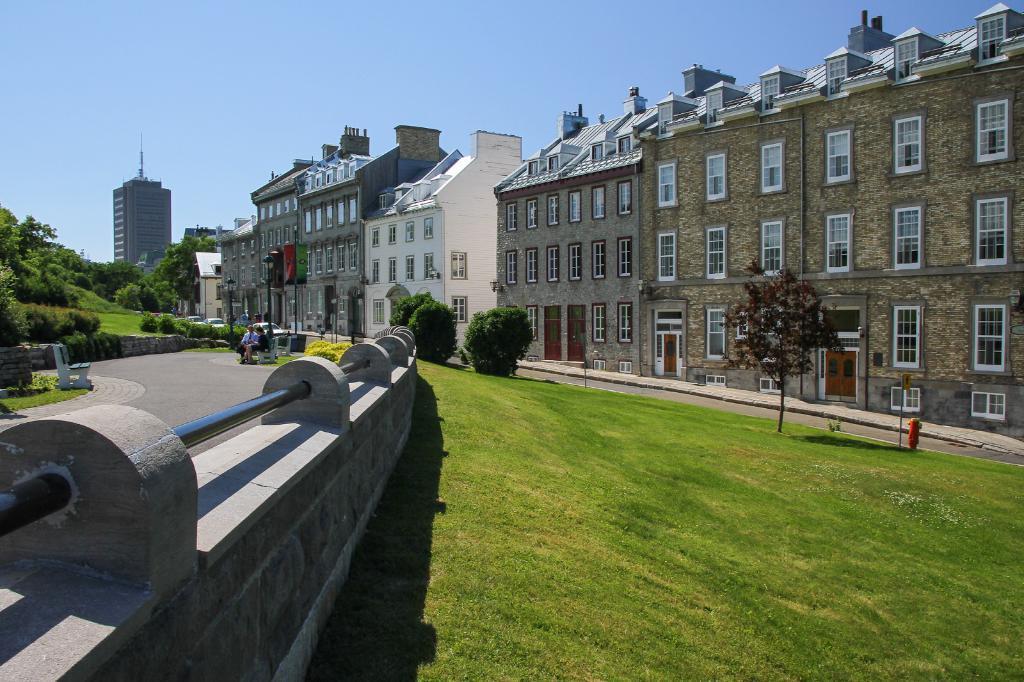How would you summarize this image in a sentence or two? In this image we can see a group of buildings with windows. We can also see the flags, a group of trees, plants, grass, the fire extinguisher and some vehicles on the pathway. On the left side we can see two people sitting on a bench, a fence with some metal poles, an empty bench and the sky which looks cloudy. 